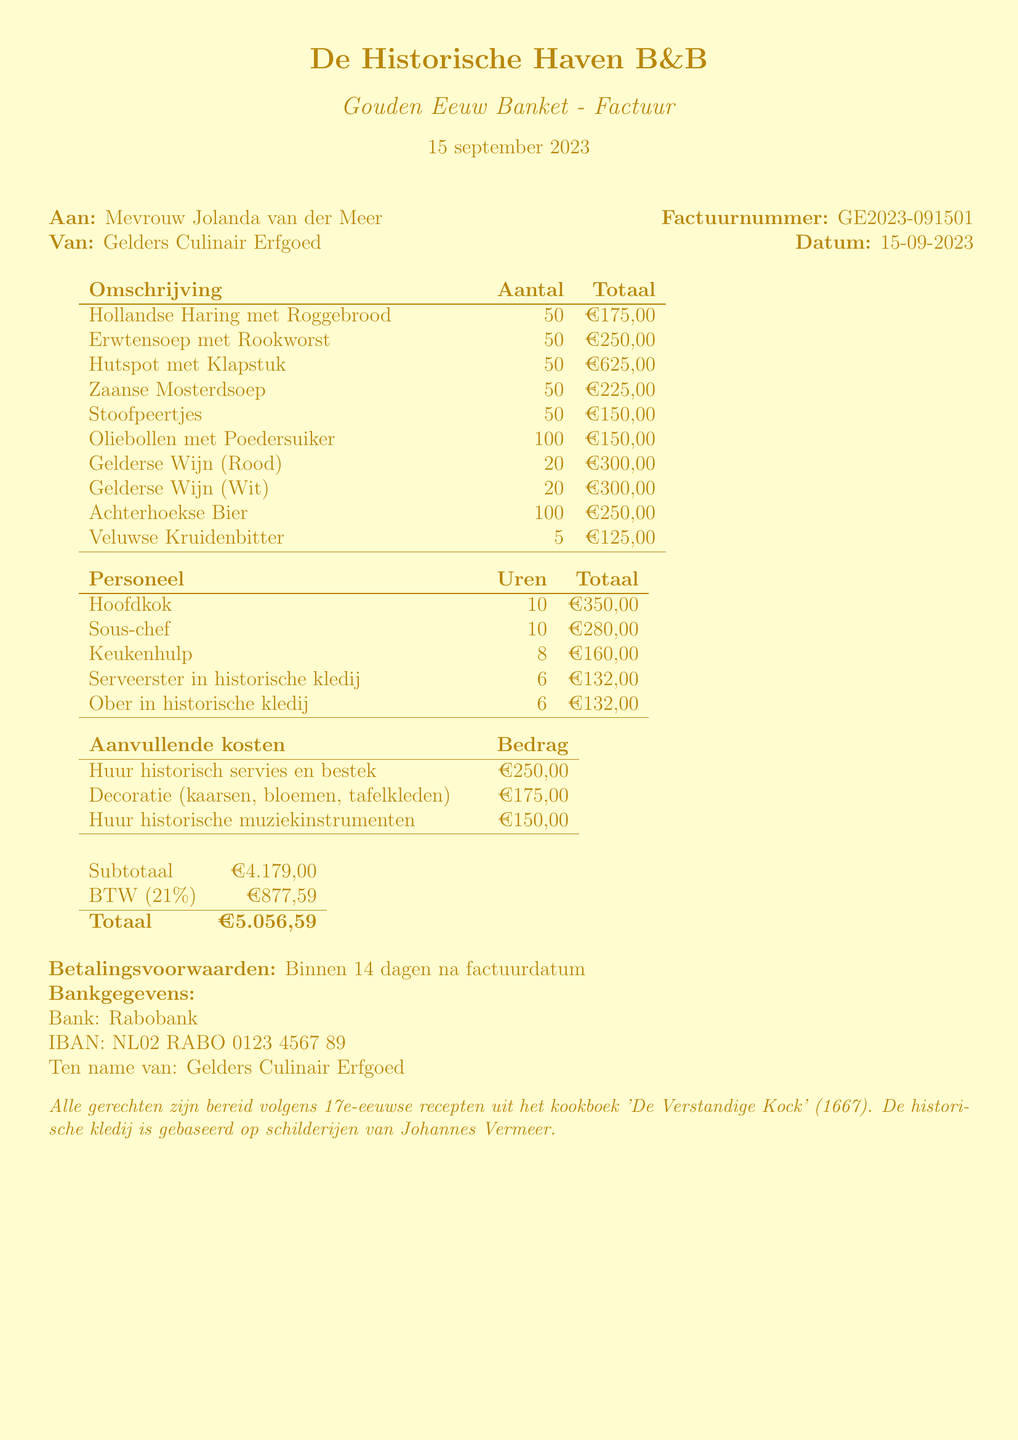What is the business name? The document identifies the business name as the one providing the catering services.
Answer: De Historische Haven B&B Who is the client? The client name is mentioned at the beginning of the document.
Answer: Mevrouw Jolanda van der Meer What is the event date? The date of the event is specified in the document's header section.
Answer: 15 september 2023 What is the total amount due? The total amount is calculated in the financial summary at the end of the document.
Answer: €5.056,59 How many different menu items are listed? The document presents a list of itemized food and drink offerings, which can be counted.
Answer: 10 What is the total cost for drinks? The total cost is found by summing the costs of all beverage items listed.
Answer: €975,00 What role had the highest staff cost? The staff costs section shows each role and the corresponding total cost.
Answer: Hoofdkok What are the payment terms? Payment conditions are stated near the end of the document.
Answer: Binnen 14 dagen na factuurdatum What is the subtotal before tax? The subtotal is explicitly mentioned in the financial section of the document.
Answer: €4.179,00 What is included in the special notes section? The special notes section provides additional details regarding historical context and preparation.
Answer: Alle gerechten zijn bereid volgens 17e-eeuwse recepten uit het kookboek 'De Verstandige Kock' (1667). De historische kledij is gebaseerd op schilderijen van Johannes Vermeer 